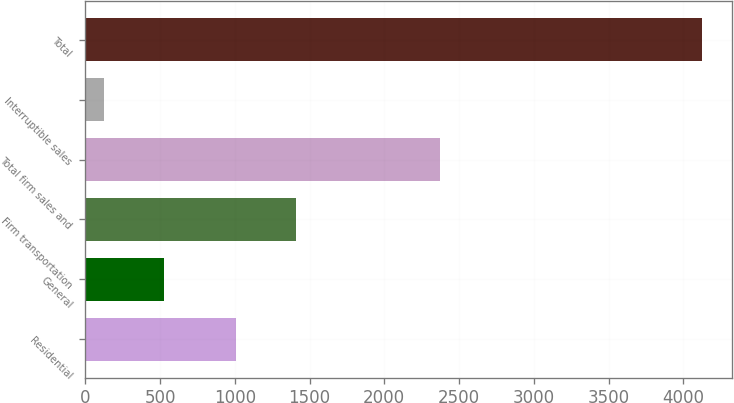Convert chart. <chart><loc_0><loc_0><loc_500><loc_500><bar_chart><fcel>Residential<fcel>General<fcel>Firm transportation<fcel>Total firm sales and<fcel>Interruptible sales<fcel>Total<nl><fcel>1010<fcel>526.5<fcel>1409.5<fcel>2374<fcel>127<fcel>4122<nl></chart> 